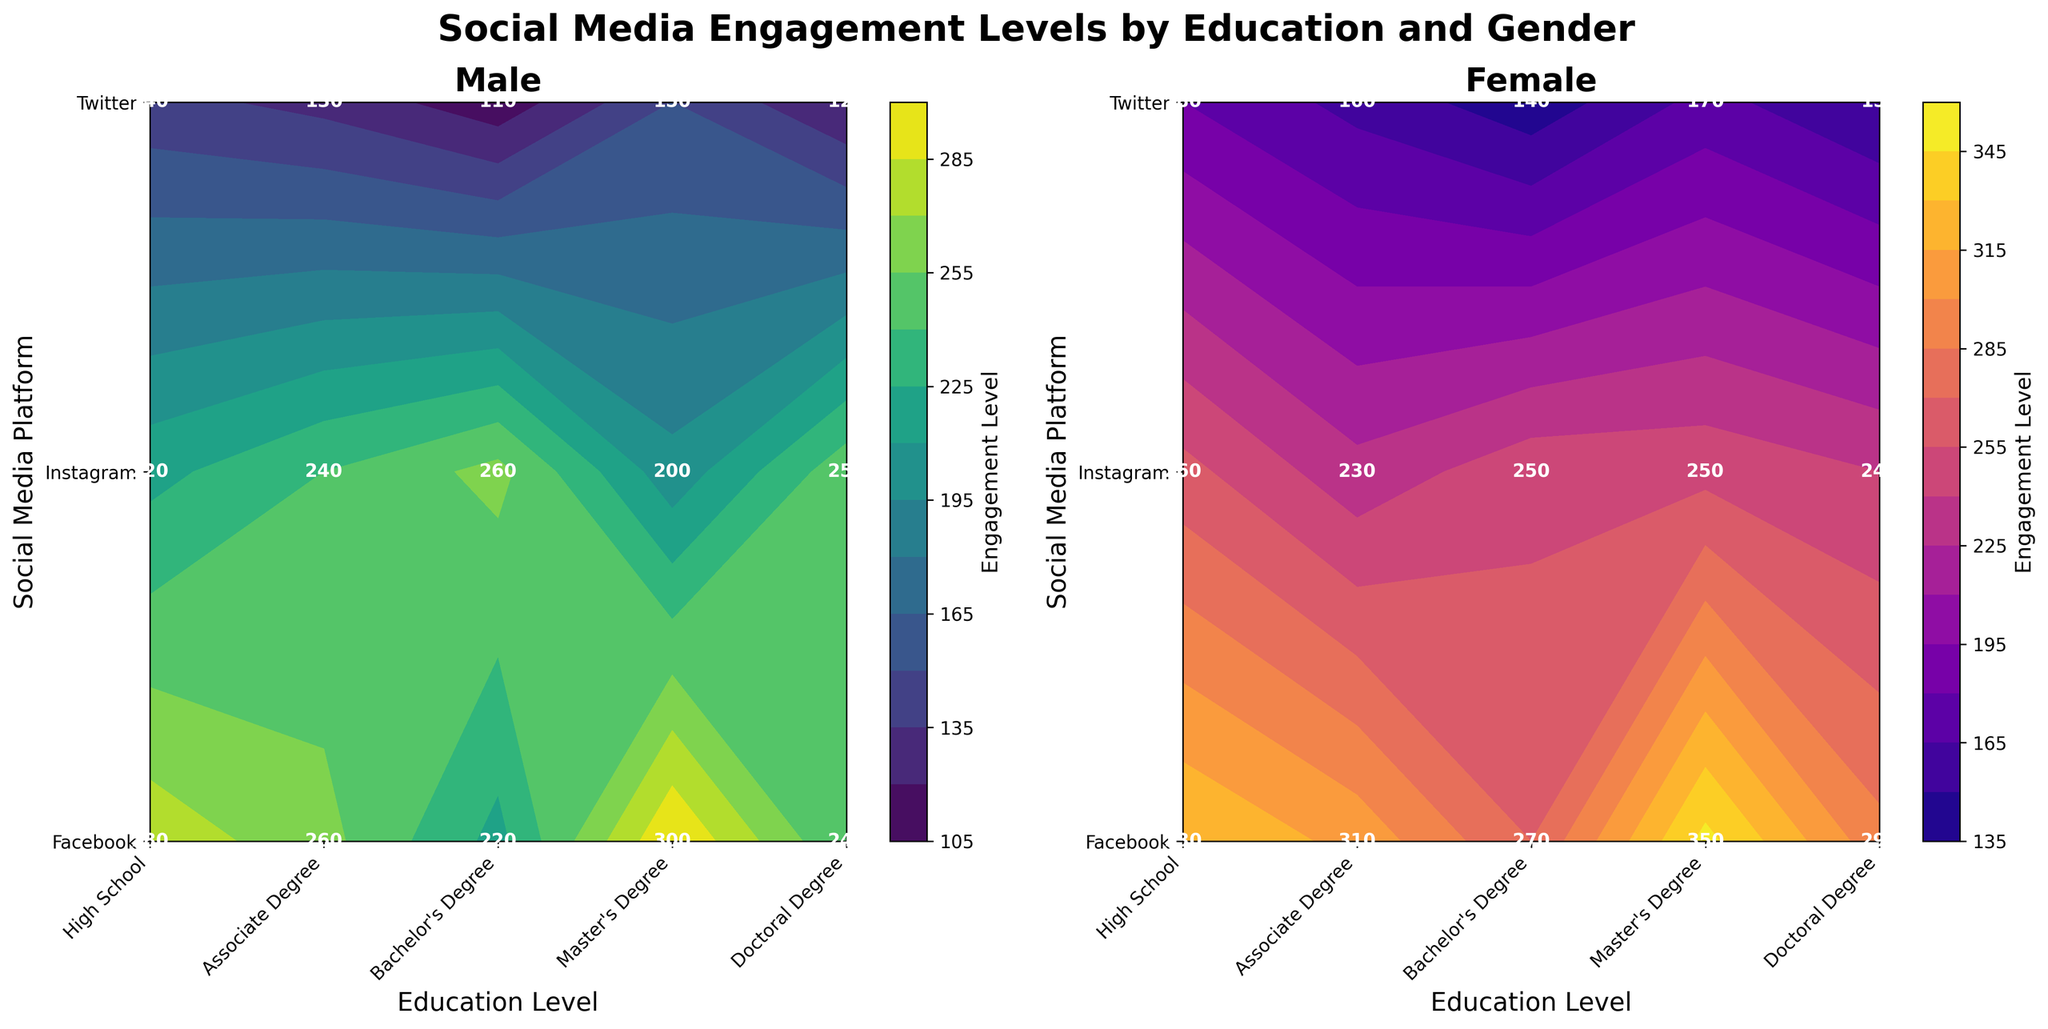What are the two color themes used in the figure? The figure uses different color themes for the male and female plots. The male plot uses a viridis color theme, which ranges from dark purple to bright yellow-green. The female plot uses a plasma color theme, ranging from dark blue to bright yellow. These color themes help visually distinguish the two gender groups.
Answer: viridis and plasma How many distinct education levels are analyzed in the figure? The x-axis labels show the different education levels analyzed in the figure. The distinct education levels include 'High School', 'Associate Degree', 'Bachelor's Degree', 'Master's Degree', and 'Doctoral Degree'. By counting these, we can determine the number of distinct education levels.
Answer: Five Which social media platform sees the highest engagement level for males with a high school education? Looking at the contour plot for males and referring to the education level 'High School' on the x-axis and 'Facebook' on the y-axis, we see the highest engagement level is 300. This is confirmed by noticing that Facebook has a higher contour fill in the male plot as compared to Instagram and Twitter for the same education level.
Answer: Facebook What is the engagement level of females with a bachelor's degree on Instagram? Referring to the female plot, locate the intersection of 'Bachelor's Degree' on the x-axis and 'Instagram' on the y-axis. The numeric label at this point indicates the engagement level. For females, this value is 230.
Answer: 230 What is the average engagement level on Twitter for males across all education levels? To find this, we sum the engagement levels for males on Twitter across all education levels ('High School', 'Associate Degree', 'Bachelor's Degree', 'Master's Degree', 'Doctoral Degree') and then divide by the number of values. The engagement levels are 150, 140, 130, 120, and 110. So, (150 + 140 + 130 + 120 + 110) / 5 = 650 / 5 = 130.
Answer: 130 Which social media platform has the lowest engagement level for females with a doctoral degree? In the female plot, for 'Doctoral Degree' on the x-axis, compare the engagement levels for all three social media platforms. Twitter shows the lowest engagement level of 140 as compared to 270 for Facebook and 250 for Instagram.
Answer: Twitter Compare the engagement level on Facebook between males with a master's degree and females with an associate degree. From the plots, look up the engagement levels of males with a master's degree on Facebook and females with an associate degree on Facebook. For the male plot: Master's degree on Facebook is 240. For the female plot: Associate degree on Facebook is 330. Comparing these two, females with an associate degree have a higher engagement level.
Answer: Females with an associate degree What is the sum of engagement levels for females on all social media platforms at the associate degree level? Adding the engagement levels for females on Facebook, Instagram, and Twitter at the associate degree level: 330 + 260 + 180. Summing them gives 330 + 260 + 180 = 770.
Answer: 770 What is the difference in engagement levels on Instagram between males and females with a master’s degree? Refer to the contour plots for both males and females. For males, the engagement level on Instagram with a master's degree is 250. For females, the engagement level on Instagram with a master's degree is 240. The difference is 250 - 240 = 10.
Answer: 10 